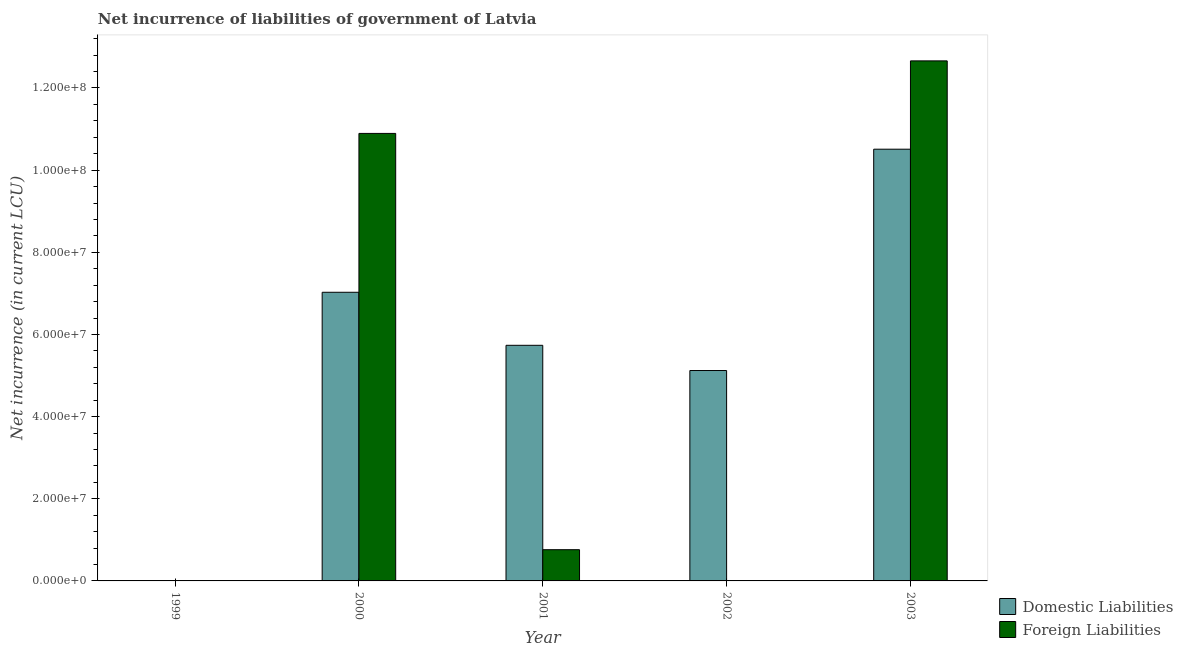How many different coloured bars are there?
Your answer should be very brief. 2. Are the number of bars per tick equal to the number of legend labels?
Offer a very short reply. No. How many bars are there on the 2nd tick from the left?
Offer a very short reply. 2. In how many cases, is the number of bars for a given year not equal to the number of legend labels?
Your answer should be compact. 2. Across all years, what is the maximum net incurrence of foreign liabilities?
Offer a terse response. 1.27e+08. What is the total net incurrence of domestic liabilities in the graph?
Make the answer very short. 2.84e+08. What is the difference between the net incurrence of domestic liabilities in 2002 and that in 2003?
Make the answer very short. -5.39e+07. What is the difference between the net incurrence of foreign liabilities in 2000 and the net incurrence of domestic liabilities in 1999?
Offer a terse response. 1.09e+08. What is the average net incurrence of domestic liabilities per year?
Provide a succinct answer. 5.68e+07. In the year 2003, what is the difference between the net incurrence of domestic liabilities and net incurrence of foreign liabilities?
Offer a terse response. 0. In how many years, is the net incurrence of domestic liabilities greater than 24000000 LCU?
Provide a short and direct response. 4. What is the ratio of the net incurrence of domestic liabilities in 2000 to that in 2003?
Offer a very short reply. 0.67. What is the difference between the highest and the second highest net incurrence of foreign liabilities?
Your answer should be very brief. 1.77e+07. What is the difference between the highest and the lowest net incurrence of foreign liabilities?
Keep it short and to the point. 1.27e+08. In how many years, is the net incurrence of domestic liabilities greater than the average net incurrence of domestic liabilities taken over all years?
Provide a succinct answer. 3. Is the sum of the net incurrence of foreign liabilities in 2001 and 2003 greater than the maximum net incurrence of domestic liabilities across all years?
Make the answer very short. Yes. How many bars are there?
Offer a terse response. 7. Are all the bars in the graph horizontal?
Your response must be concise. No. What is the difference between two consecutive major ticks on the Y-axis?
Provide a short and direct response. 2.00e+07. Does the graph contain any zero values?
Ensure brevity in your answer.  Yes. What is the title of the graph?
Give a very brief answer. Net incurrence of liabilities of government of Latvia. What is the label or title of the X-axis?
Offer a very short reply. Year. What is the label or title of the Y-axis?
Offer a very short reply. Net incurrence (in current LCU). What is the Net incurrence (in current LCU) of Domestic Liabilities in 2000?
Ensure brevity in your answer.  7.03e+07. What is the Net incurrence (in current LCU) in Foreign Liabilities in 2000?
Ensure brevity in your answer.  1.09e+08. What is the Net incurrence (in current LCU) in Domestic Liabilities in 2001?
Keep it short and to the point. 5.74e+07. What is the Net incurrence (in current LCU) in Foreign Liabilities in 2001?
Your answer should be compact. 7.60e+06. What is the Net incurrence (in current LCU) of Domestic Liabilities in 2002?
Offer a terse response. 5.12e+07. What is the Net incurrence (in current LCU) in Foreign Liabilities in 2002?
Give a very brief answer. 0. What is the Net incurrence (in current LCU) of Domestic Liabilities in 2003?
Your answer should be compact. 1.05e+08. What is the Net incurrence (in current LCU) of Foreign Liabilities in 2003?
Offer a terse response. 1.27e+08. Across all years, what is the maximum Net incurrence (in current LCU) in Domestic Liabilities?
Provide a short and direct response. 1.05e+08. Across all years, what is the maximum Net incurrence (in current LCU) in Foreign Liabilities?
Offer a terse response. 1.27e+08. Across all years, what is the minimum Net incurrence (in current LCU) in Foreign Liabilities?
Offer a terse response. 0. What is the total Net incurrence (in current LCU) of Domestic Liabilities in the graph?
Give a very brief answer. 2.84e+08. What is the total Net incurrence (in current LCU) of Foreign Liabilities in the graph?
Your answer should be compact. 2.43e+08. What is the difference between the Net incurrence (in current LCU) of Domestic Liabilities in 2000 and that in 2001?
Ensure brevity in your answer.  1.29e+07. What is the difference between the Net incurrence (in current LCU) in Foreign Liabilities in 2000 and that in 2001?
Make the answer very short. 1.01e+08. What is the difference between the Net incurrence (in current LCU) in Domestic Liabilities in 2000 and that in 2002?
Provide a succinct answer. 1.90e+07. What is the difference between the Net incurrence (in current LCU) of Domestic Liabilities in 2000 and that in 2003?
Offer a terse response. -3.48e+07. What is the difference between the Net incurrence (in current LCU) in Foreign Liabilities in 2000 and that in 2003?
Your response must be concise. -1.77e+07. What is the difference between the Net incurrence (in current LCU) of Domestic Liabilities in 2001 and that in 2002?
Offer a terse response. 6.14e+06. What is the difference between the Net incurrence (in current LCU) of Domestic Liabilities in 2001 and that in 2003?
Offer a terse response. -4.77e+07. What is the difference between the Net incurrence (in current LCU) in Foreign Liabilities in 2001 and that in 2003?
Give a very brief answer. -1.19e+08. What is the difference between the Net incurrence (in current LCU) in Domestic Liabilities in 2002 and that in 2003?
Your answer should be very brief. -5.39e+07. What is the difference between the Net incurrence (in current LCU) in Domestic Liabilities in 2000 and the Net incurrence (in current LCU) in Foreign Liabilities in 2001?
Provide a short and direct response. 6.27e+07. What is the difference between the Net incurrence (in current LCU) in Domestic Liabilities in 2000 and the Net incurrence (in current LCU) in Foreign Liabilities in 2003?
Provide a short and direct response. -5.63e+07. What is the difference between the Net incurrence (in current LCU) of Domestic Liabilities in 2001 and the Net incurrence (in current LCU) of Foreign Liabilities in 2003?
Make the answer very short. -6.92e+07. What is the difference between the Net incurrence (in current LCU) in Domestic Liabilities in 2002 and the Net incurrence (in current LCU) in Foreign Liabilities in 2003?
Your response must be concise. -7.54e+07. What is the average Net incurrence (in current LCU) of Domestic Liabilities per year?
Your answer should be compact. 5.68e+07. What is the average Net incurrence (in current LCU) in Foreign Liabilities per year?
Make the answer very short. 4.86e+07. In the year 2000, what is the difference between the Net incurrence (in current LCU) in Domestic Liabilities and Net incurrence (in current LCU) in Foreign Liabilities?
Keep it short and to the point. -3.87e+07. In the year 2001, what is the difference between the Net incurrence (in current LCU) in Domestic Liabilities and Net incurrence (in current LCU) in Foreign Liabilities?
Ensure brevity in your answer.  4.98e+07. In the year 2003, what is the difference between the Net incurrence (in current LCU) of Domestic Liabilities and Net incurrence (in current LCU) of Foreign Liabilities?
Give a very brief answer. -2.15e+07. What is the ratio of the Net incurrence (in current LCU) in Domestic Liabilities in 2000 to that in 2001?
Offer a very short reply. 1.23. What is the ratio of the Net incurrence (in current LCU) of Foreign Liabilities in 2000 to that in 2001?
Offer a terse response. 14.33. What is the ratio of the Net incurrence (in current LCU) in Domestic Liabilities in 2000 to that in 2002?
Offer a terse response. 1.37. What is the ratio of the Net incurrence (in current LCU) in Domestic Liabilities in 2000 to that in 2003?
Offer a terse response. 0.67. What is the ratio of the Net incurrence (in current LCU) in Foreign Liabilities in 2000 to that in 2003?
Provide a succinct answer. 0.86. What is the ratio of the Net incurrence (in current LCU) of Domestic Liabilities in 2001 to that in 2002?
Offer a very short reply. 1.12. What is the ratio of the Net incurrence (in current LCU) of Domestic Liabilities in 2001 to that in 2003?
Provide a succinct answer. 0.55. What is the ratio of the Net incurrence (in current LCU) of Domestic Liabilities in 2002 to that in 2003?
Your answer should be very brief. 0.49. What is the difference between the highest and the second highest Net incurrence (in current LCU) of Domestic Liabilities?
Keep it short and to the point. 3.48e+07. What is the difference between the highest and the second highest Net incurrence (in current LCU) of Foreign Liabilities?
Your response must be concise. 1.77e+07. What is the difference between the highest and the lowest Net incurrence (in current LCU) of Domestic Liabilities?
Offer a very short reply. 1.05e+08. What is the difference between the highest and the lowest Net incurrence (in current LCU) in Foreign Liabilities?
Your response must be concise. 1.27e+08. 